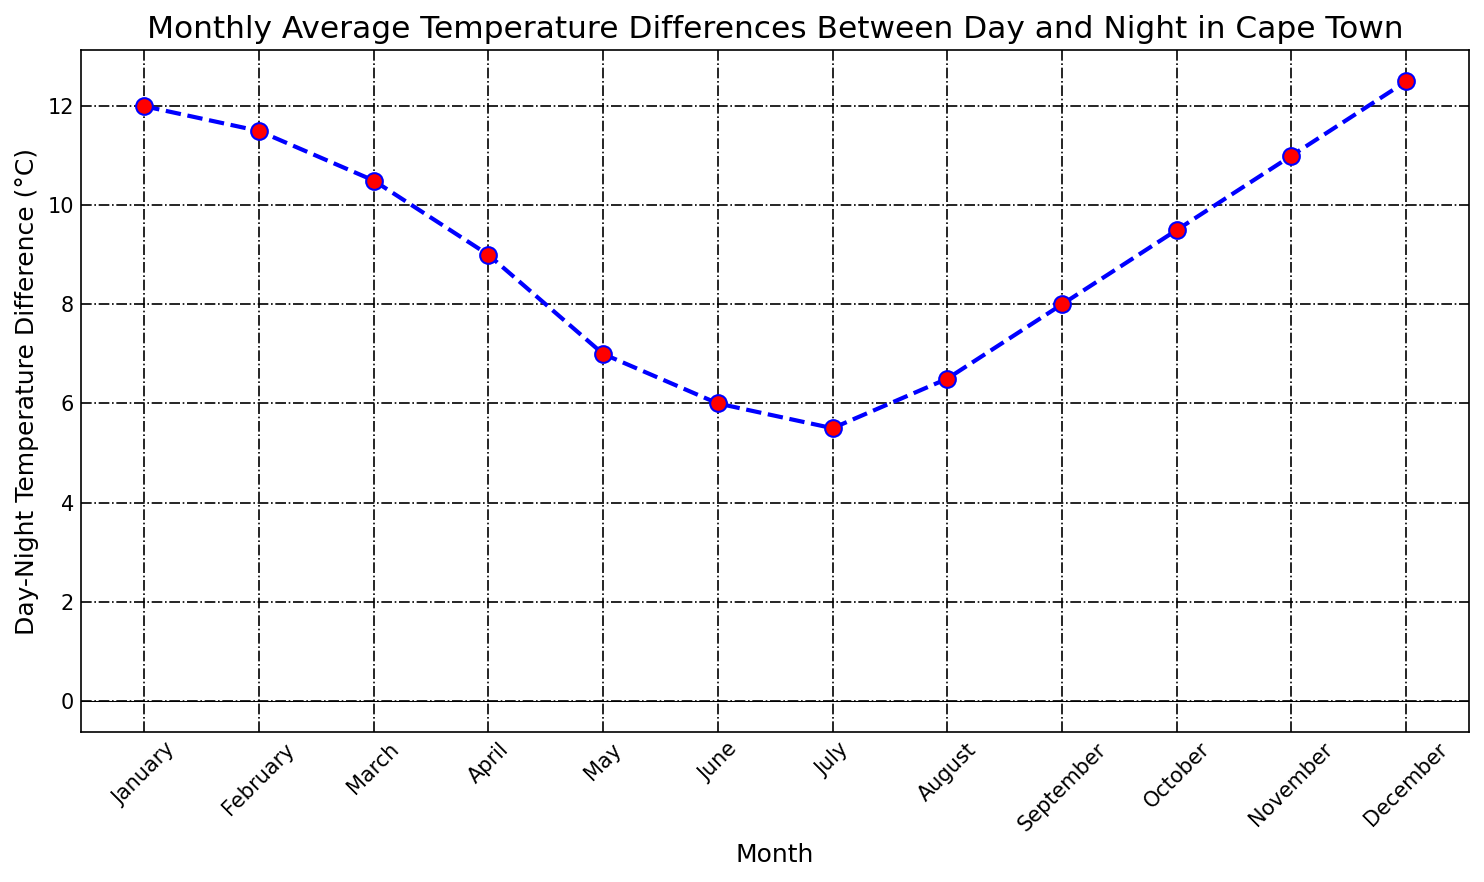What is the month with the highest day-night temperature difference? By inspecting the plotted points, the highest point occurs in December with a value of 12.5°C.
Answer: December Which month has the lowest day-night temperature difference? By observing the lowest point on the line chart, July registers the lowest difference at 5.5°C.
Answer: July How does the day-night temperature difference in April compare to that in October? From the chart, April's difference is 9°C and October's difference is 9.5°C. October's difference is 0.5°C higher than April's.
Answer: October is 0.5°C higher In which months is the day-night temperature difference greater than 10°C? The months where the line goes above 10°C are January, February, November, and December.
Answer: January, February, November, December What is the average day-night temperature difference for the entire year? Sum all the monthly differences (12 + 11.5 + 10.5 + 9 + 7 + 6 + 5.5 + 6.5 + 8 + 9.5 + 11 + 12.5 = 108), then divide by 12. The average is 108/12 = 9°C.
Answer: 9°C Which two consecutive months have the largest decrease in day-night temperature difference? By visual inspection, the largest drop occurs from January (12°C) to February (11.5°C). The decrease is 0.5°C. Other months should be carefully reviewed the same way, but the largest drop is from April (9°C) to May (7°C), resulting in a 2°C decrease.
Answer: April to May If the day-night temperature difference in May increased by 2°C, what would be the new average for the year? If May's difference rises to 9°C, recalculate: (12 + 11.5 + 10.5 + 9 + 9 + 6 + 5.5 + 6.5 + 8 + 9.5 + 11 + 12.5) = 110.5. The new average is 110.5/12 = 9.21°C.
Answer: 9.21°C Is the temperature difference greater in March or November? By checking both points, March has 10.5°C while November has 11°C. Therefore, November has a greater difference.
Answer: November How many months have a day-night temperature difference less than the yearly average? The annual average is 9°C. Months with differences below 9°C are May, June, July, and August — 4 months in total.
Answer: 4 months 